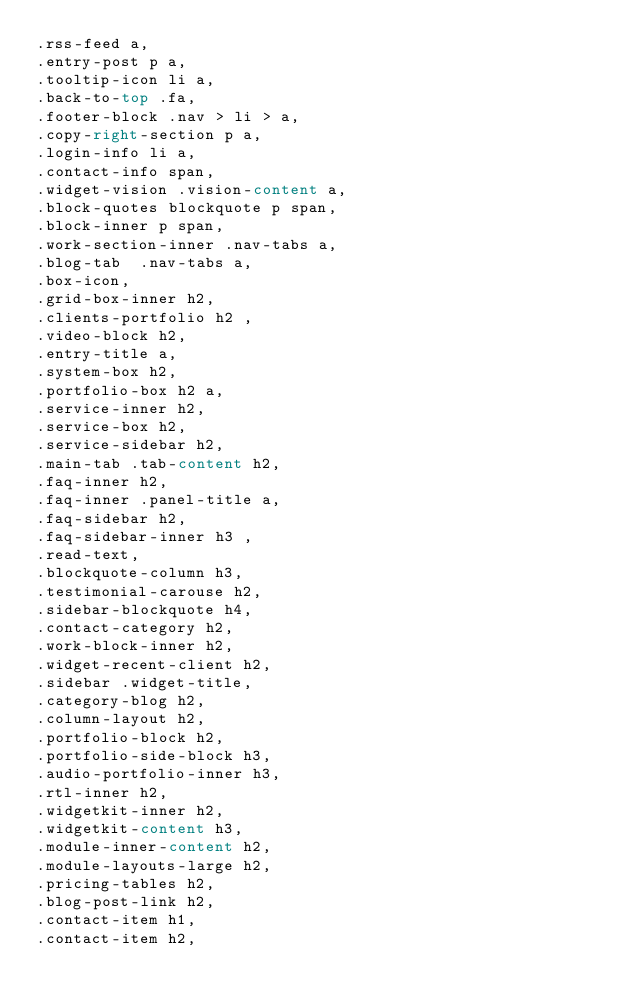<code> <loc_0><loc_0><loc_500><loc_500><_CSS_>.rss-feed a,
.entry-post p a,
.tooltip-icon li a,
.back-to-top .fa,
.footer-block .nav > li > a,
.copy-right-section p a,
.login-info li a,
.contact-info span,
.widget-vision .vision-content a, 
.block-quotes blockquote p span,
.block-inner p span,
.work-section-inner .nav-tabs a, 
.blog-tab  .nav-tabs a,
.box-icon,
.grid-box-inner h2,
.clients-portfolio h2 ,
.video-block h2,
.entry-title a,
.system-box h2,
.portfolio-box h2 a,
.service-inner h2,
.service-box h2,
.service-sidebar h2,
.main-tab .tab-content h2,
.faq-inner h2,
.faq-inner .panel-title a,
.faq-sidebar h2,
.faq-sidebar-inner h3 ,
.read-text,
.blockquote-column h3,
.testimonial-carouse h2,
.sidebar-blockquote h4,
.contact-category h2,
.work-block-inner h2,
.widget-recent-client h2,
.sidebar .widget-title,
.category-blog h2,
.column-layout h2,
.portfolio-block h2,
.portfolio-side-block h3,
.audio-portfolio-inner h3,
.rtl-inner h2,
.widgetkit-inner h2,
.widgetkit-content h3,
.module-inner-content h2,
.module-layouts-large h2,
.pricing-tables h2,
.blog-post-link h2,
.contact-item h1,
.contact-item h2,</code> 